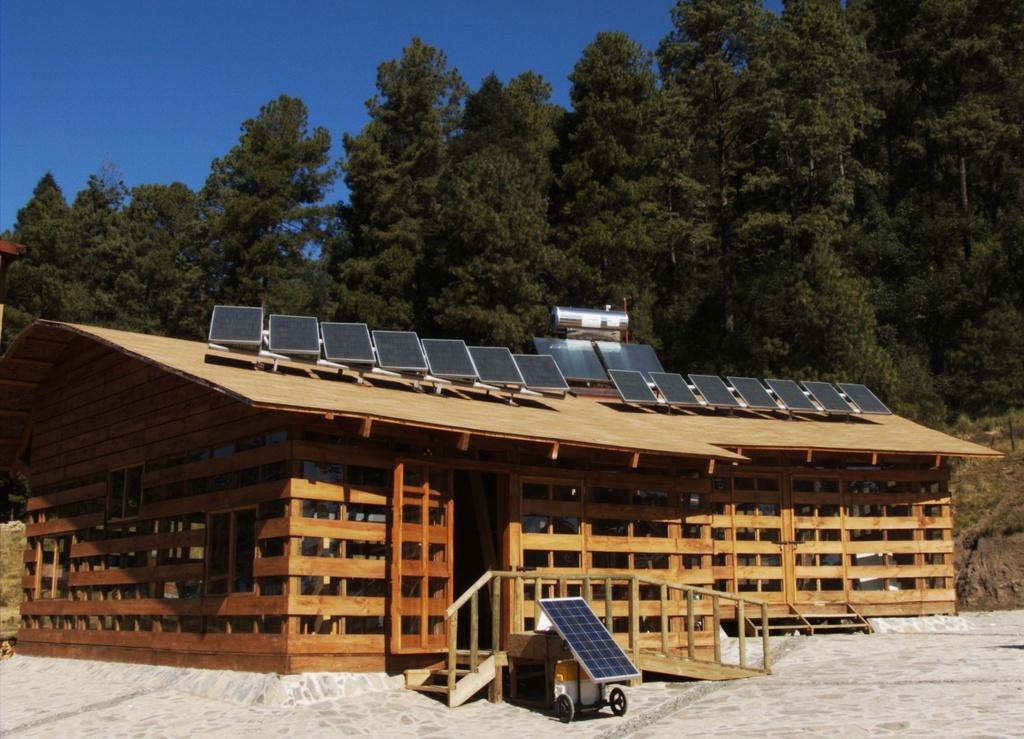Could you give a brief overview of what you see in this image? In this picture I can see a wooden house on which I can see some objects. In the background I can see trees and the sky. Here I can see steps and some other object on the ground. 